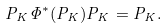<formula> <loc_0><loc_0><loc_500><loc_500>P _ { K } \Phi ^ { * } ( P _ { K } ) P _ { K } = P _ { K } .</formula> 